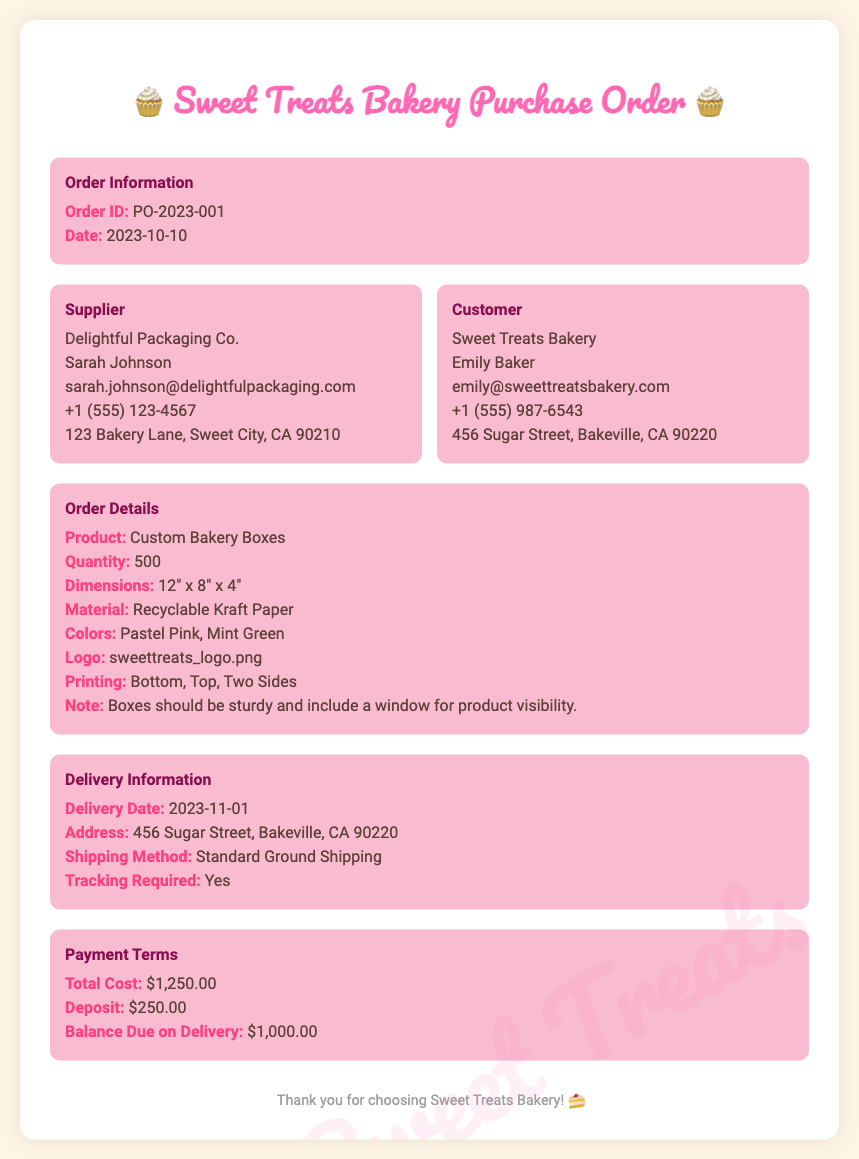What is the Order ID? The Order ID is found in the Order Information section of the document.
Answer: PO-2023-001 Who is the supplier? The supplier's name is listed in the Supplier section of the document.
Answer: Delightful Packaging Co What is the quantity of custom bakery boxes ordered? The quantity can be found in the Order Details section of the document.
Answer: 500 What is the total cost? The total cost is mentioned in the Payment Terms section of the document.
Answer: $1,250.00 What is the delivery date? The delivery date is specified in the Delivery Information section of the document.
Answer: 2023-11-01 What colors are specified for the boxes? The colors of the boxes are listed in the Order Details section of the document.
Answer: Pastel Pink, Mint Green Who is the customer representative's name? The customer representative's name is provided in the Customer section of the document.
Answer: Emily Baker What is noted about the boxes? The note regarding the boxes is stated in the Order Details section of the document.
Answer: Boxes should be sturdy and include a window for product visibility 